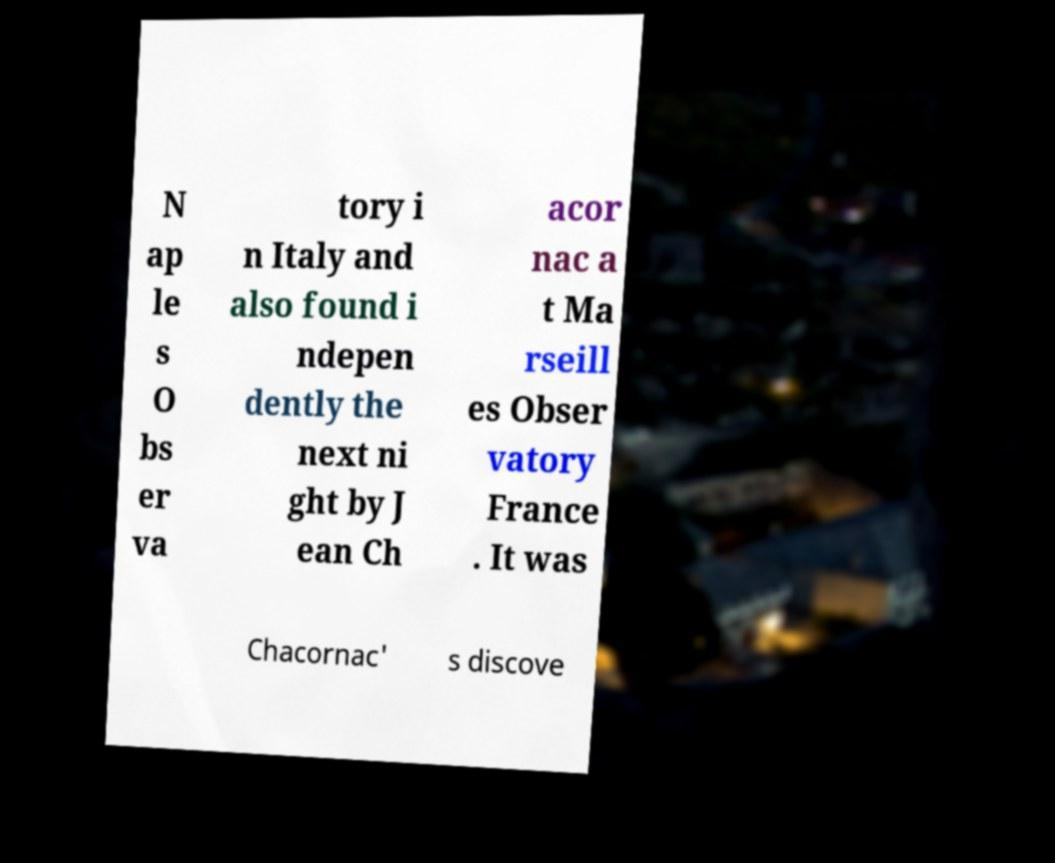There's text embedded in this image that I need extracted. Can you transcribe it verbatim? N ap le s O bs er va tory i n Italy and also found i ndepen dently the next ni ght by J ean Ch acor nac a t Ma rseill es Obser vatory France . It was Chacornac' s discove 